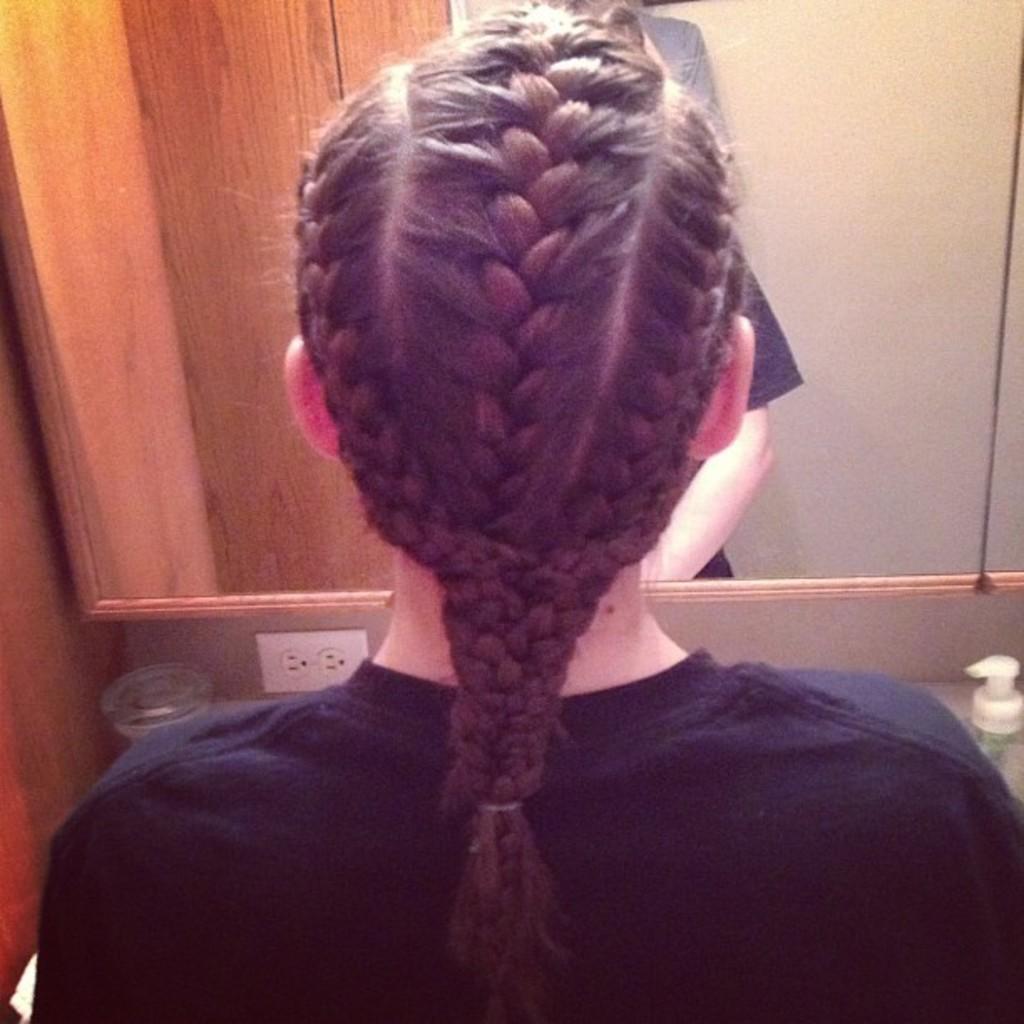Could you give a brief overview of what you see in this image? In this image there is a girls braid in the middle. In front of her there is a mirror. 